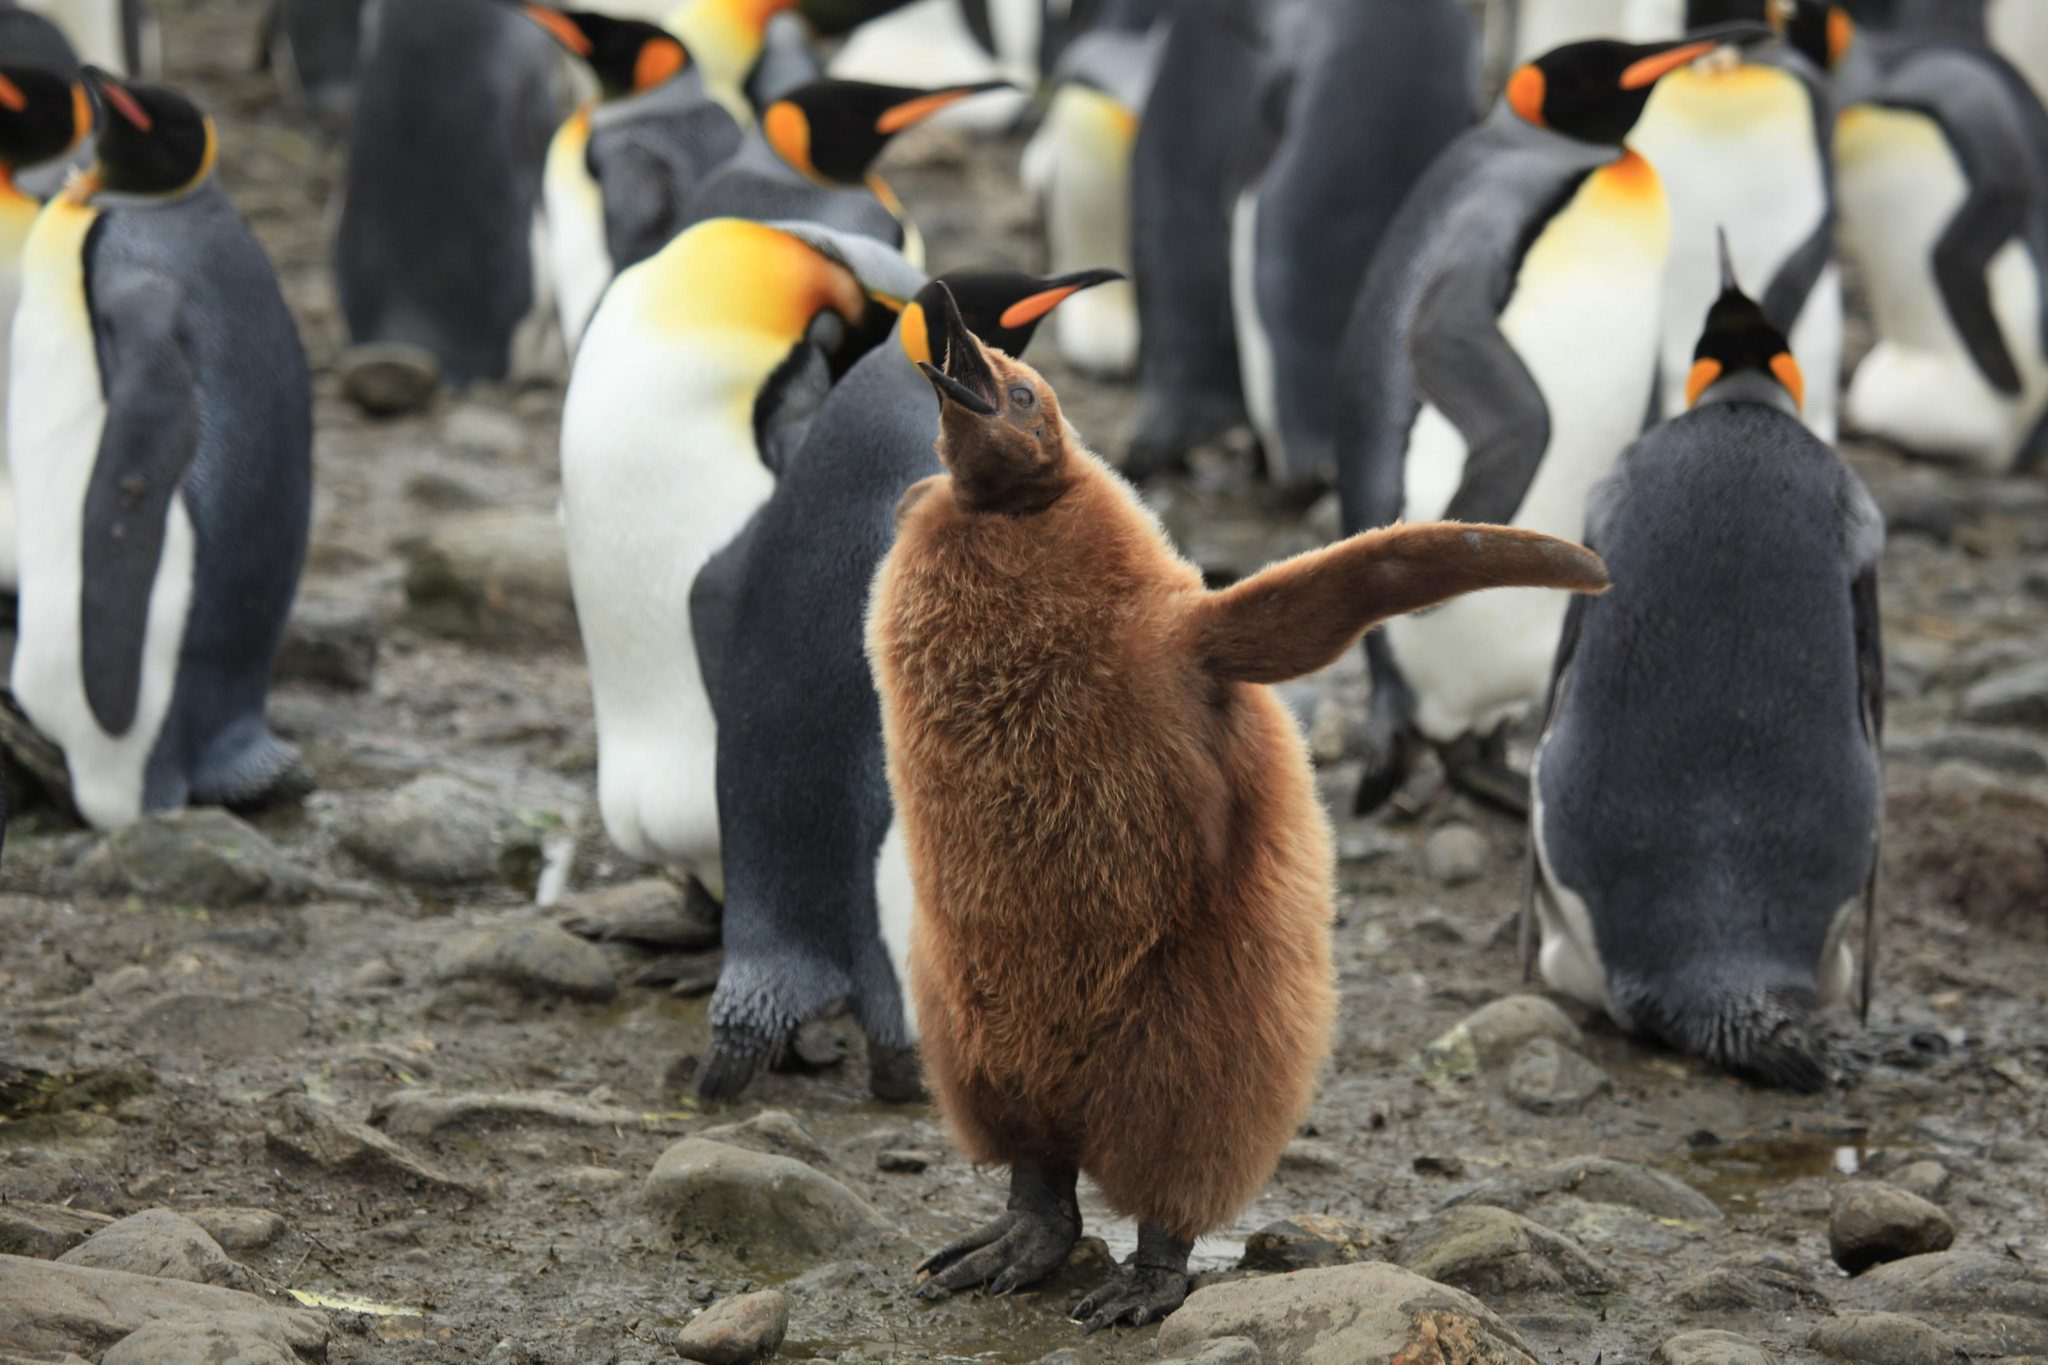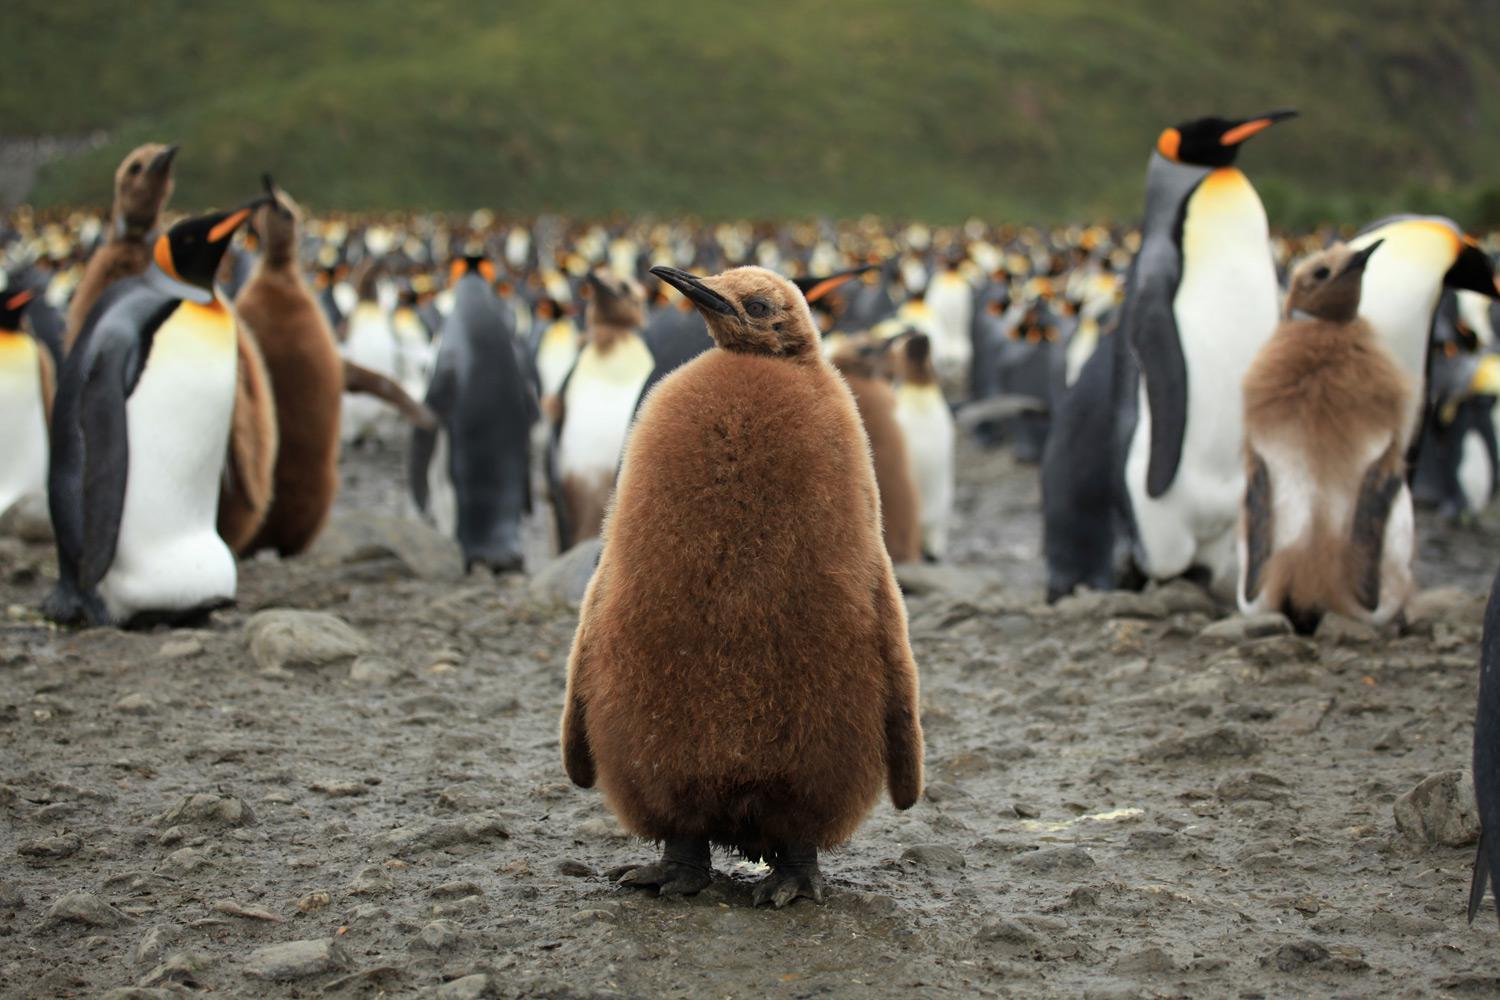The first image is the image on the left, the second image is the image on the right. Given the left and right images, does the statement "In the right image, a fuzzy brown penguin stands by itself, with other penguins in the background." hold true? Answer yes or no. Yes. The first image is the image on the left, the second image is the image on the right. Evaluate the accuracy of this statement regarding the images: "One of the images contains visible grass.". Is it true? Answer yes or no. Yes. The first image is the image on the left, the second image is the image on the right. Analyze the images presented: Is the assertion "There is one seal on the ground in one of the images." valid? Answer yes or no. No. The first image is the image on the left, the second image is the image on the right. Examine the images to the left and right. Is the description "The ocean is visible." accurate? Answer yes or no. No. 